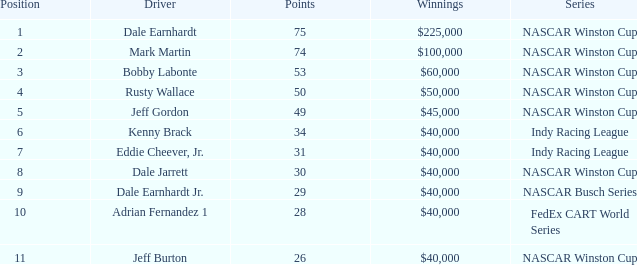How much did Jeff Burton win? $40,000. 